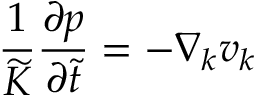Convert formula to latex. <formula><loc_0><loc_0><loc_500><loc_500>\frac { 1 } { \widetilde { K } } \frac { \partial p } { \partial \widetilde { t } } = - \nabla _ { k } v _ { k }</formula> 